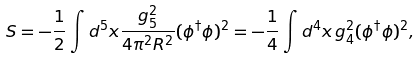<formula> <loc_0><loc_0><loc_500><loc_500>S = - \frac { 1 } { 2 } \int d ^ { 5 } x \frac { g _ { 5 } ^ { 2 } } { 4 \pi ^ { 2 } R ^ { 2 } } ( \phi ^ { \dagger } \phi ) ^ { 2 } = - \frac { 1 } { 4 } \int d ^ { 4 } x \, g _ { 4 } ^ { 2 } ( \phi ^ { \dagger } \phi ) ^ { 2 } ,</formula> 